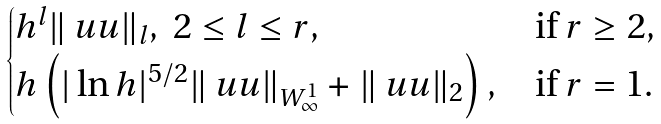Convert formula to latex. <formula><loc_0><loc_0><loc_500><loc_500>\begin{cases} h ^ { l } \| \ u u \| _ { l } , \ 2 \leq l \leq r , & \text {if $r\geq 2$} , \\ h \left ( | \ln h | ^ { 5 / 2 } \| \ u u \| _ { W ^ { 1 } _ { \infty } } + \| \ u u \| _ { 2 } \right ) , & \text {if $r=1$} . \end{cases}</formula> 